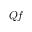<formula> <loc_0><loc_0><loc_500><loc_500>Q f</formula> 